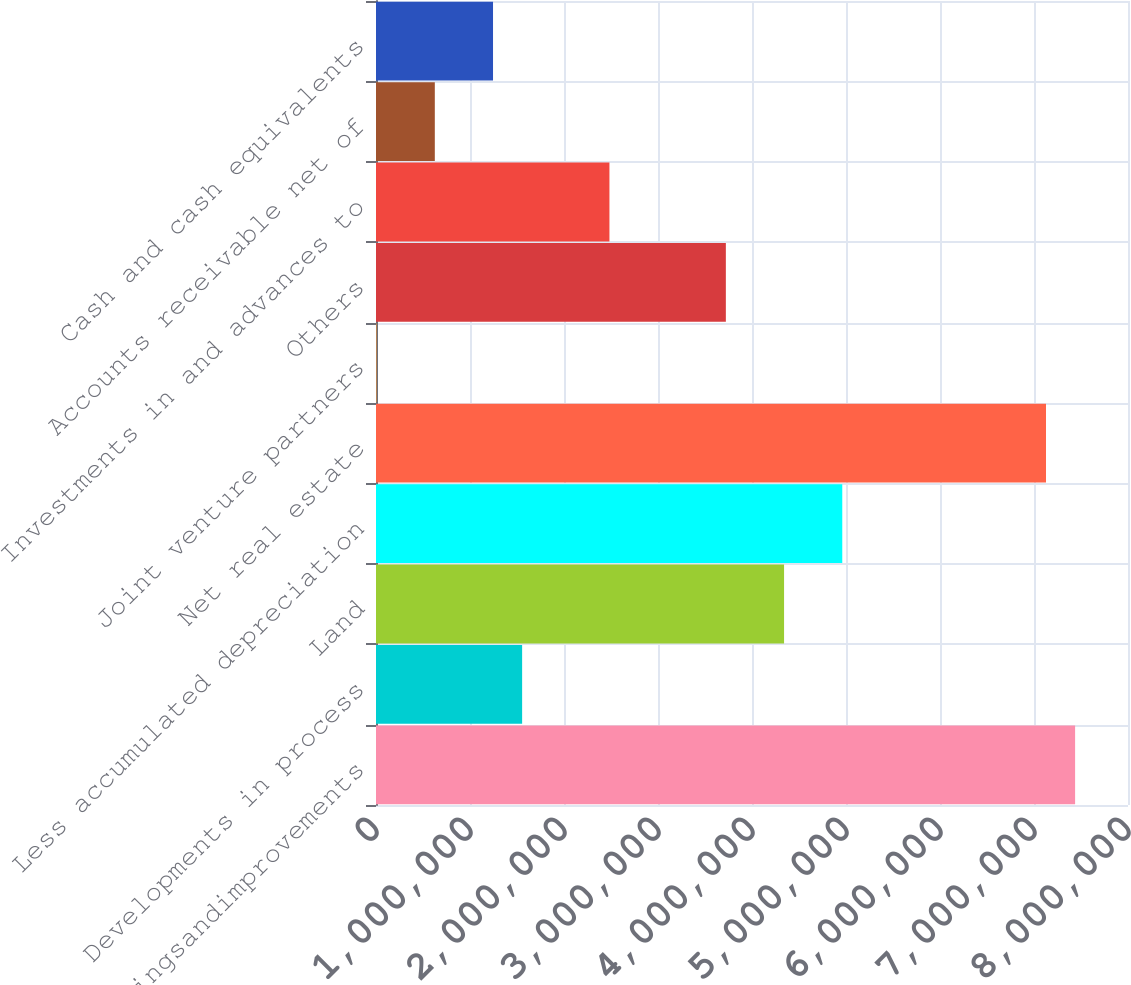Convert chart to OTSL. <chart><loc_0><loc_0><loc_500><loc_500><bar_chart><fcel>Buildingsandimprovements<fcel>Developments in process<fcel>Land<fcel>Less accumulated depreciation<fcel>Net real estate<fcel>Joint venture partners<fcel>Others<fcel>Investments in and advances to<fcel>Accounts receivable net of<fcel>Cash and cash equivalents<nl><fcel>7.43726e+06<fcel>1.55455e+06<fcel>4.3411e+06<fcel>4.96033e+06<fcel>7.12764e+06<fcel>6473<fcel>3.72187e+06<fcel>2.4834e+06<fcel>625705<fcel>1.24494e+06<nl></chart> 